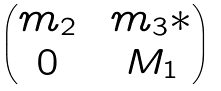Convert formula to latex. <formula><loc_0><loc_0><loc_500><loc_500>\begin{pmatrix} m _ { 2 } & & m _ { 3 } * \\ 0 & & M _ { 1 } \end{pmatrix}</formula> 